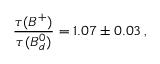<formula> <loc_0><loc_0><loc_500><loc_500>\frac { \tau ( B ^ { + } ) } { \tau ( B _ { d } ^ { 0 } ) } = 1 . 0 7 \pm 0 . 0 3 \, ,</formula> 